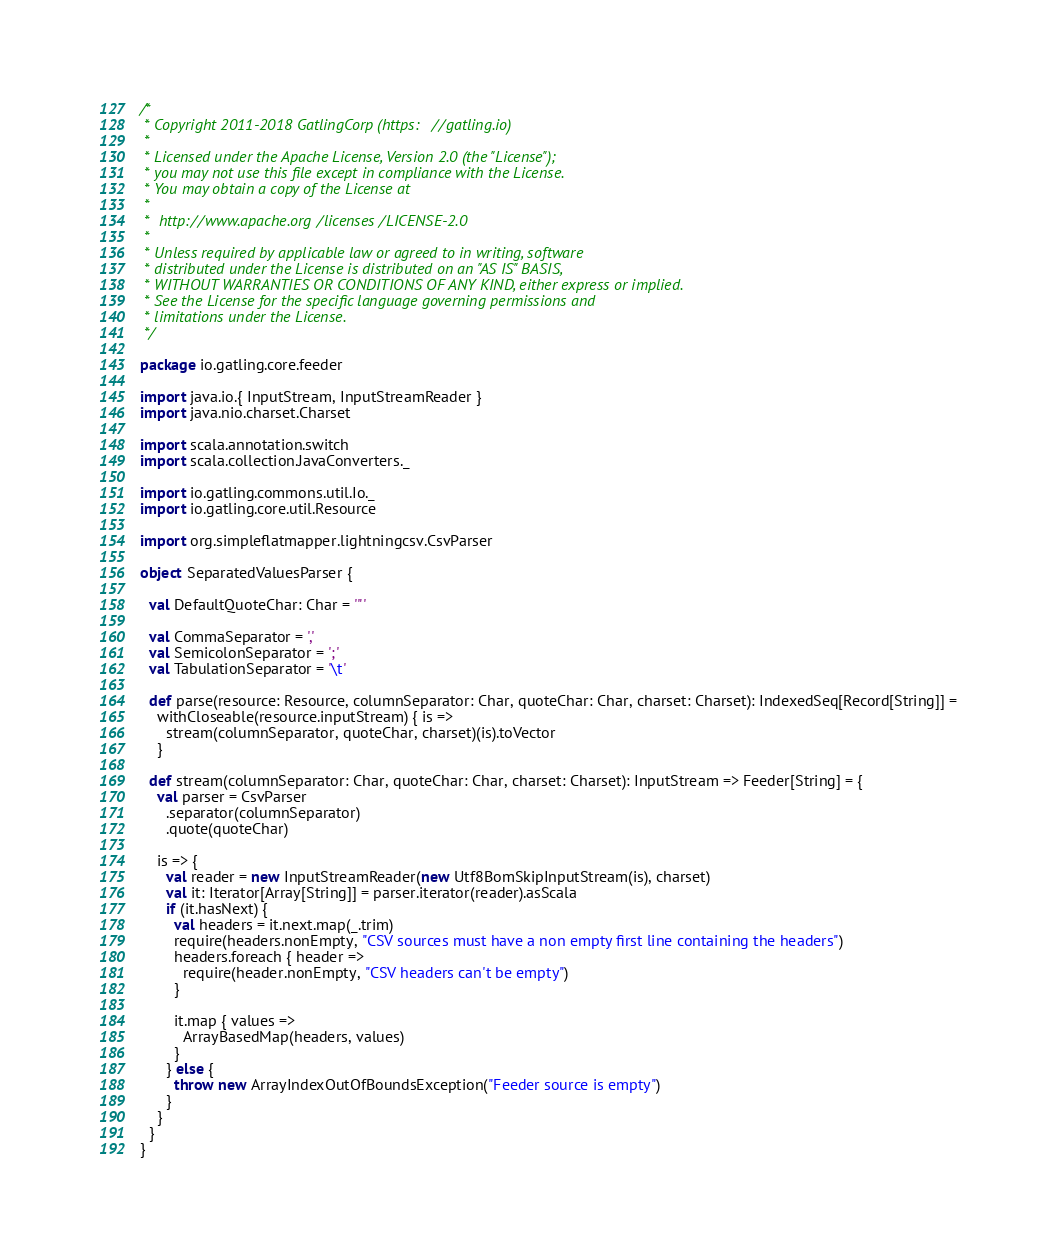<code> <loc_0><loc_0><loc_500><loc_500><_Scala_>/*
 * Copyright 2011-2018 GatlingCorp (https://gatling.io)
 *
 * Licensed under the Apache License, Version 2.0 (the "License");
 * you may not use this file except in compliance with the License.
 * You may obtain a copy of the License at
 *
 *  http://www.apache.org/licenses/LICENSE-2.0
 *
 * Unless required by applicable law or agreed to in writing, software
 * distributed under the License is distributed on an "AS IS" BASIS,
 * WITHOUT WARRANTIES OR CONDITIONS OF ANY KIND, either express or implied.
 * See the License for the specific language governing permissions and
 * limitations under the License.
 */

package io.gatling.core.feeder

import java.io.{ InputStream, InputStreamReader }
import java.nio.charset.Charset

import scala.annotation.switch
import scala.collection.JavaConverters._

import io.gatling.commons.util.Io._
import io.gatling.core.util.Resource

import org.simpleflatmapper.lightningcsv.CsvParser

object SeparatedValuesParser {

  val DefaultQuoteChar: Char = '"'

  val CommaSeparator = ','
  val SemicolonSeparator = ';'
  val TabulationSeparator = '\t'

  def parse(resource: Resource, columnSeparator: Char, quoteChar: Char, charset: Charset): IndexedSeq[Record[String]] =
    withCloseable(resource.inputStream) { is =>
      stream(columnSeparator, quoteChar, charset)(is).toVector
    }

  def stream(columnSeparator: Char, quoteChar: Char, charset: Charset): InputStream => Feeder[String] = {
    val parser = CsvParser
      .separator(columnSeparator)
      .quote(quoteChar)

    is => {
      val reader = new InputStreamReader(new Utf8BomSkipInputStream(is), charset)
      val it: Iterator[Array[String]] = parser.iterator(reader).asScala
      if (it.hasNext) {
        val headers = it.next.map(_.trim)
        require(headers.nonEmpty, "CSV sources must have a non empty first line containing the headers")
        headers.foreach { header =>
          require(header.nonEmpty, "CSV headers can't be empty")
        }

        it.map { values =>
          ArrayBasedMap(headers, values)
        }
      } else {
        throw new ArrayIndexOutOfBoundsException("Feeder source is empty")
      }
    }
  }
}
</code> 